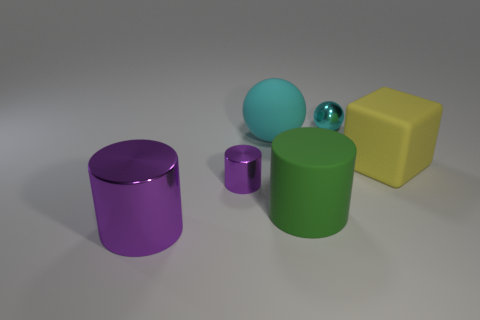There is a rubber object that is the same color as the tiny sphere; what is its size?
Your answer should be very brief. Large. Is the yellow thing made of the same material as the tiny ball?
Provide a short and direct response. No. Are there an equal number of large shiny cylinders to the right of the big yellow block and yellow rubber things that are on the left side of the big cyan thing?
Your response must be concise. Yes. What is the material of the tiny cyan object that is the same shape as the large cyan matte thing?
Ensure brevity in your answer.  Metal. The cyan thing that is behind the cyan sphere that is in front of the metallic thing behind the yellow block is what shape?
Your answer should be very brief. Sphere. Is the number of big cylinders that are to the left of the big green matte object greater than the number of tiny cyan matte cylinders?
Provide a short and direct response. Yes. There is a small metallic object left of the large cyan matte thing; is it the same shape as the yellow thing?
Offer a terse response. No. There is a small thing that is to the right of the tiny metal cylinder; what material is it?
Your response must be concise. Metal. What number of yellow rubber things have the same shape as the big metallic object?
Provide a short and direct response. 0. What material is the big thing on the right side of the small object right of the big cyan object?
Your answer should be compact. Rubber. 